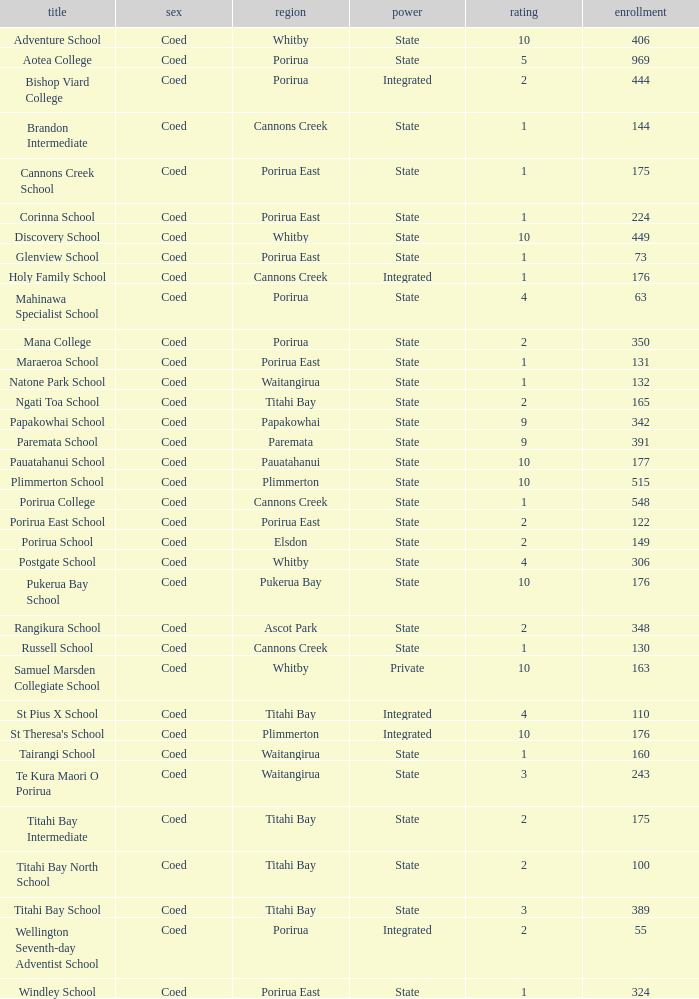What was the decile of Samuel Marsden Collegiate School in Whitby, when it had a roll higher than 163? 0.0. 